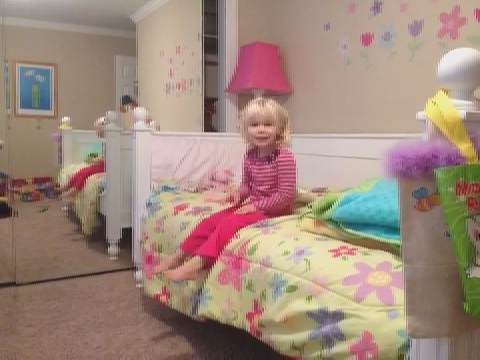Describe the objects in this image and their specific colors. I can see bed in darkgray and tan tones, people in darkgray, brown, and lightpink tones, bed in darkgray and gray tones, and people in darkgray, brown, and maroon tones in this image. 